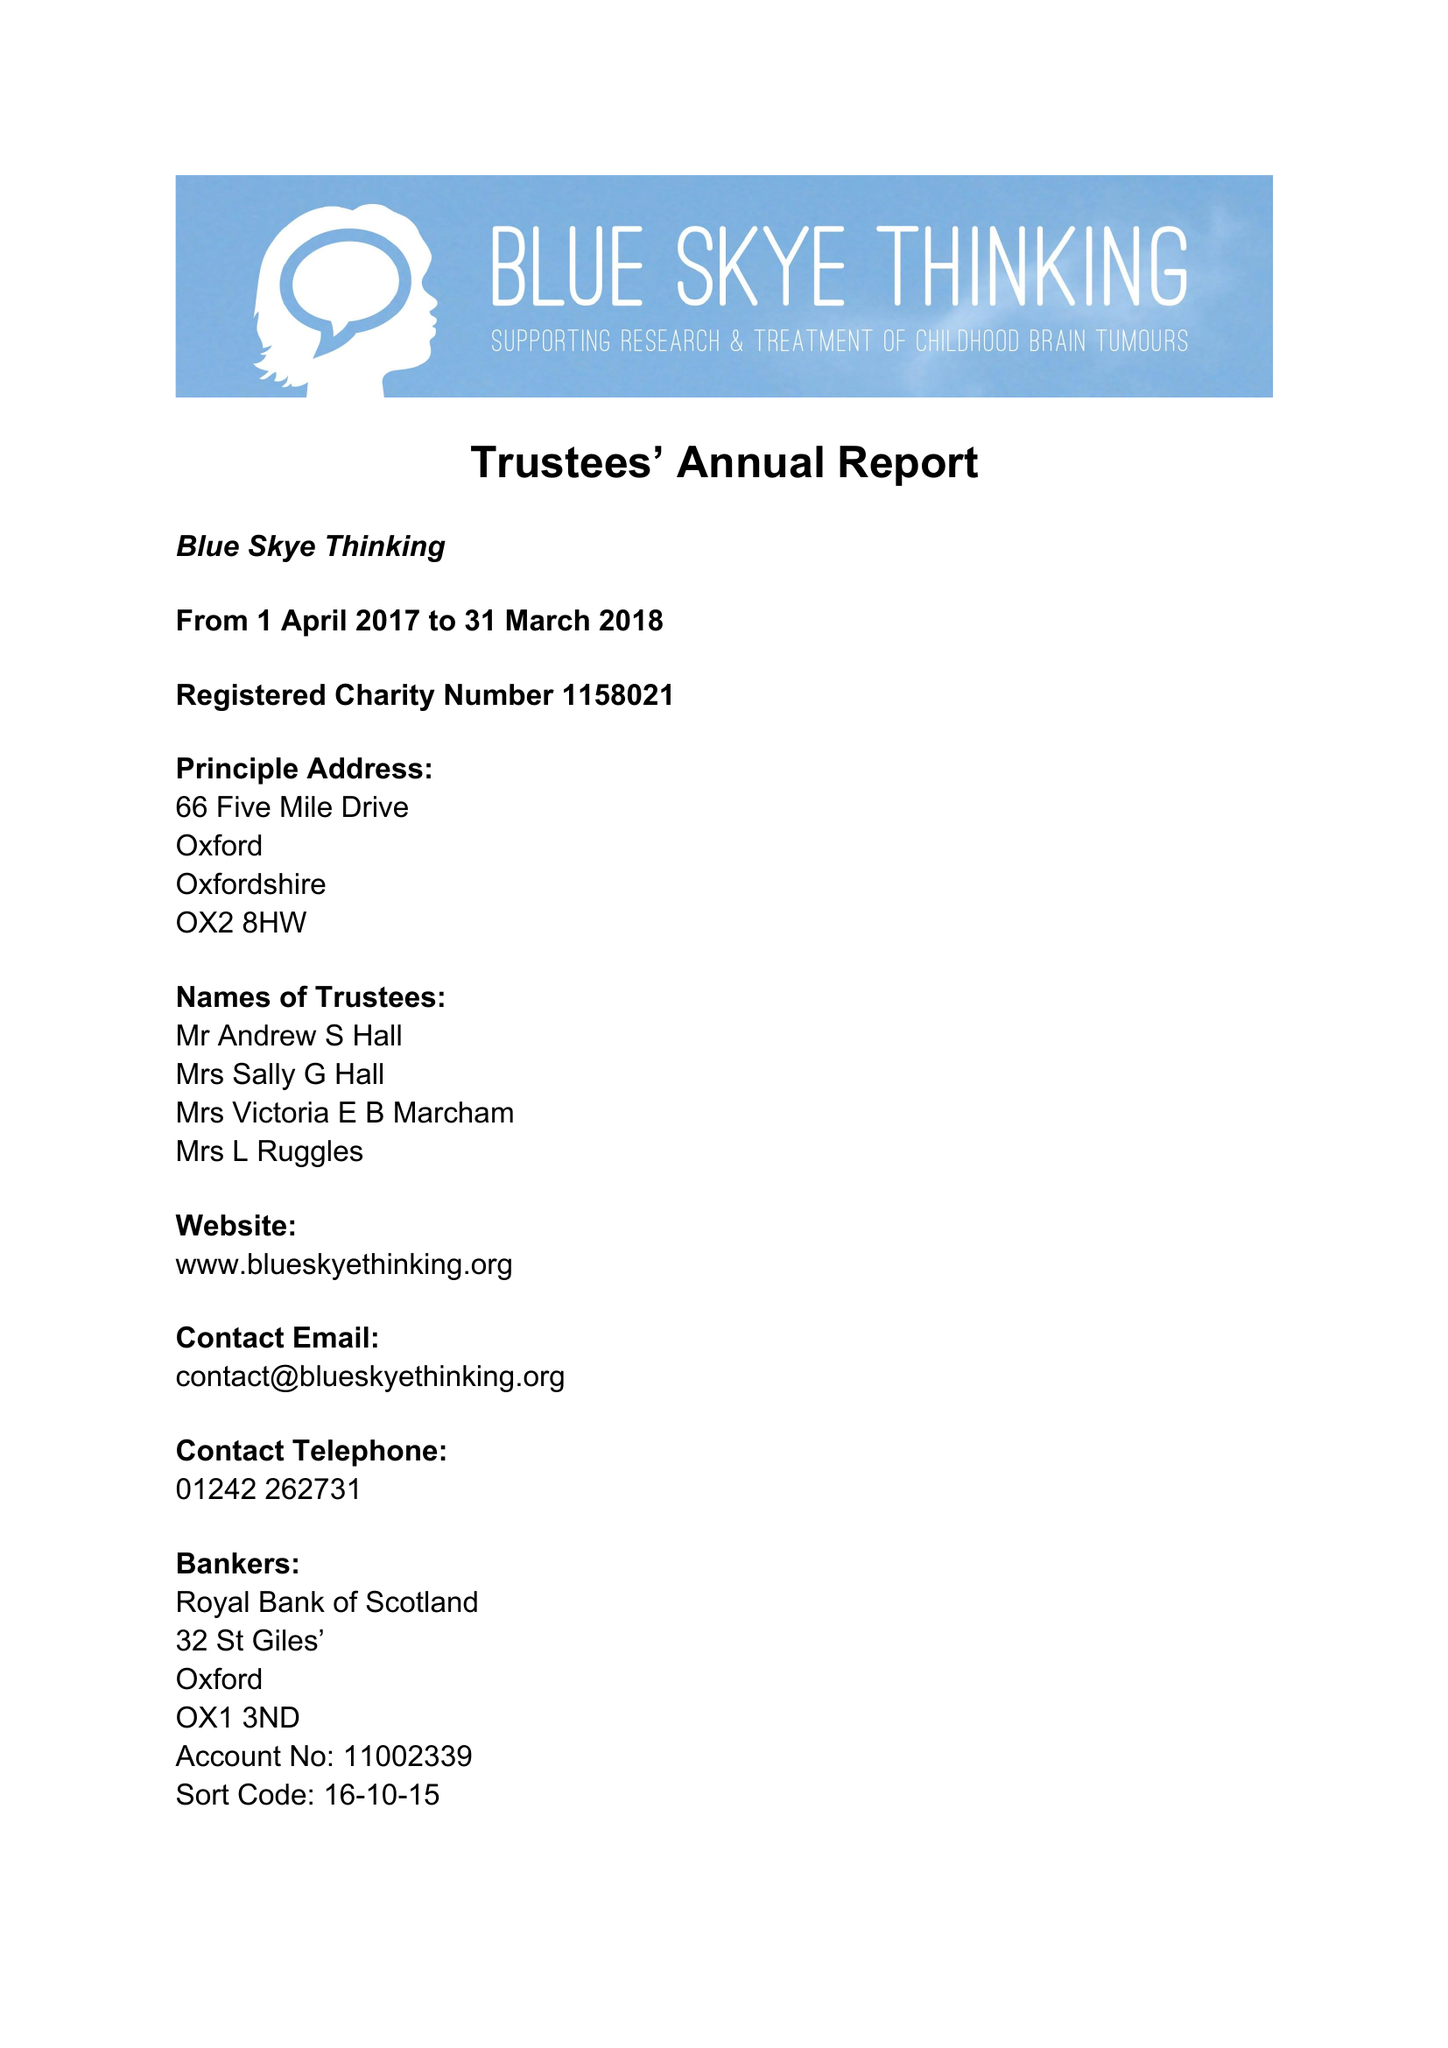What is the value for the address__street_line?
Answer the question using a single word or phrase. 66 FIVE MILE DRIVE 